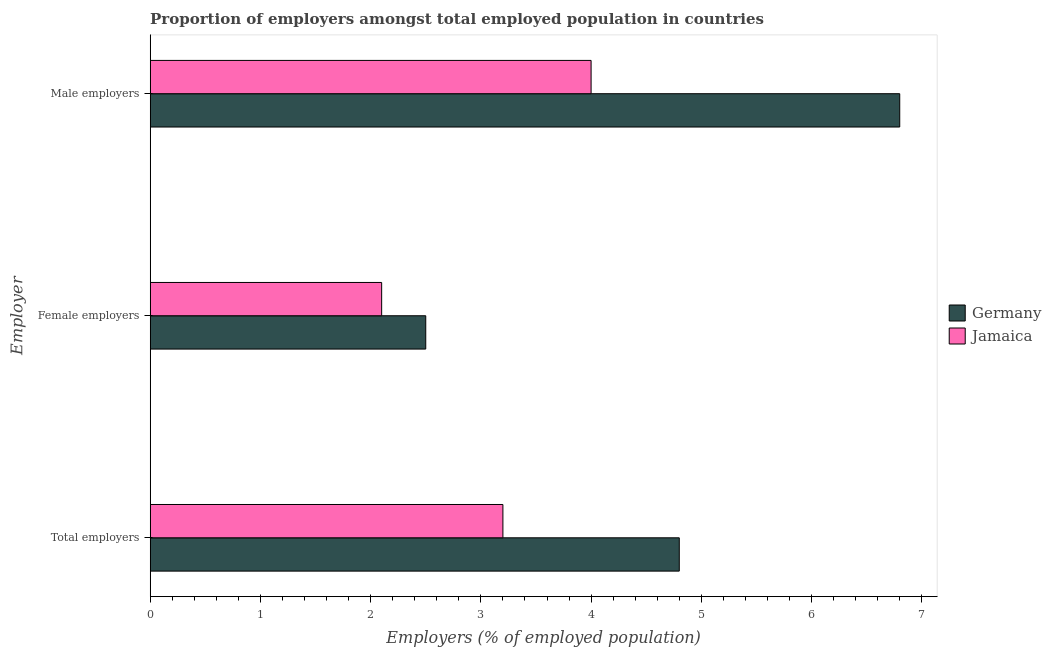How many different coloured bars are there?
Keep it short and to the point. 2. Are the number of bars on each tick of the Y-axis equal?
Provide a short and direct response. Yes. How many bars are there on the 3rd tick from the top?
Provide a succinct answer. 2. How many bars are there on the 3rd tick from the bottom?
Give a very brief answer. 2. What is the label of the 3rd group of bars from the top?
Your answer should be compact. Total employers. What is the percentage of male employers in Germany?
Your response must be concise. 6.8. Across all countries, what is the maximum percentage of male employers?
Your answer should be very brief. 6.8. Across all countries, what is the minimum percentage of total employers?
Provide a succinct answer. 3.2. In which country was the percentage of total employers minimum?
Give a very brief answer. Jamaica. What is the total percentage of male employers in the graph?
Keep it short and to the point. 10.8. What is the difference between the percentage of male employers in Germany and that in Jamaica?
Provide a short and direct response. 2.8. What is the average percentage of male employers per country?
Give a very brief answer. 5.4. What is the difference between the percentage of total employers and percentage of male employers in Jamaica?
Provide a succinct answer. -0.8. What is the ratio of the percentage of female employers in Jamaica to that in Germany?
Provide a short and direct response. 0.84. Is the percentage of male employers in Germany less than that in Jamaica?
Offer a very short reply. No. Is the difference between the percentage of male employers in Jamaica and Germany greater than the difference between the percentage of female employers in Jamaica and Germany?
Keep it short and to the point. No. What is the difference between the highest and the second highest percentage of female employers?
Your answer should be compact. 0.4. What is the difference between the highest and the lowest percentage of total employers?
Offer a terse response. 1.6. In how many countries, is the percentage of total employers greater than the average percentage of total employers taken over all countries?
Offer a terse response. 1. What does the 1st bar from the top in Male employers represents?
Offer a very short reply. Jamaica. What does the 1st bar from the bottom in Male employers represents?
Ensure brevity in your answer.  Germany. What is the difference between two consecutive major ticks on the X-axis?
Keep it short and to the point. 1. Are the values on the major ticks of X-axis written in scientific E-notation?
Offer a terse response. No. Does the graph contain grids?
Your answer should be very brief. No. Where does the legend appear in the graph?
Your answer should be very brief. Center right. How many legend labels are there?
Provide a short and direct response. 2. How are the legend labels stacked?
Your answer should be very brief. Vertical. What is the title of the graph?
Offer a very short reply. Proportion of employers amongst total employed population in countries. What is the label or title of the X-axis?
Offer a terse response. Employers (% of employed population). What is the label or title of the Y-axis?
Provide a short and direct response. Employer. What is the Employers (% of employed population) in Germany in Total employers?
Your answer should be very brief. 4.8. What is the Employers (% of employed population) of Jamaica in Total employers?
Give a very brief answer. 3.2. What is the Employers (% of employed population) of Jamaica in Female employers?
Keep it short and to the point. 2.1. What is the Employers (% of employed population) of Germany in Male employers?
Offer a very short reply. 6.8. Across all Employer, what is the maximum Employers (% of employed population) of Germany?
Offer a very short reply. 6.8. Across all Employer, what is the maximum Employers (% of employed population) of Jamaica?
Your response must be concise. 4. Across all Employer, what is the minimum Employers (% of employed population) in Jamaica?
Ensure brevity in your answer.  2.1. What is the total Employers (% of employed population) of Jamaica in the graph?
Provide a short and direct response. 9.3. What is the difference between the Employers (% of employed population) of Germany in Total employers and that in Female employers?
Offer a very short reply. 2.3. What is the difference between the Employers (% of employed population) of Jamaica in Total employers and that in Male employers?
Offer a terse response. -0.8. What is the difference between the Employers (% of employed population) of Jamaica in Female employers and that in Male employers?
Offer a terse response. -1.9. What is the difference between the Employers (% of employed population) in Germany in Total employers and the Employers (% of employed population) in Jamaica in Female employers?
Offer a very short reply. 2.7. What is the difference between the Employers (% of employed population) in Germany in Female employers and the Employers (% of employed population) in Jamaica in Male employers?
Provide a succinct answer. -1.5. What is the average Employers (% of employed population) in Germany per Employer?
Your answer should be very brief. 4.7. What is the average Employers (% of employed population) in Jamaica per Employer?
Your answer should be compact. 3.1. What is the difference between the Employers (% of employed population) in Germany and Employers (% of employed population) in Jamaica in Total employers?
Ensure brevity in your answer.  1.6. What is the ratio of the Employers (% of employed population) in Germany in Total employers to that in Female employers?
Your answer should be compact. 1.92. What is the ratio of the Employers (% of employed population) in Jamaica in Total employers to that in Female employers?
Make the answer very short. 1.52. What is the ratio of the Employers (% of employed population) of Germany in Total employers to that in Male employers?
Your answer should be compact. 0.71. What is the ratio of the Employers (% of employed population) in Jamaica in Total employers to that in Male employers?
Ensure brevity in your answer.  0.8. What is the ratio of the Employers (% of employed population) in Germany in Female employers to that in Male employers?
Make the answer very short. 0.37. What is the ratio of the Employers (% of employed population) in Jamaica in Female employers to that in Male employers?
Keep it short and to the point. 0.53. What is the difference between the highest and the second highest Employers (% of employed population) of Germany?
Ensure brevity in your answer.  2. What is the difference between the highest and the lowest Employers (% of employed population) in Germany?
Provide a succinct answer. 4.3. What is the difference between the highest and the lowest Employers (% of employed population) of Jamaica?
Your response must be concise. 1.9. 